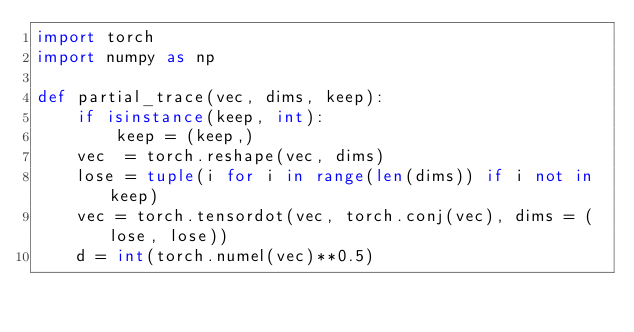<code> <loc_0><loc_0><loc_500><loc_500><_Python_>import torch
import numpy as np

def partial_trace(vec, dims, keep):
    if isinstance(keep, int):
        keep = (keep,)
    vec  = torch.reshape(vec, dims)
    lose = tuple(i for i in range(len(dims)) if i not in keep)
    vec = torch.tensordot(vec, torch.conj(vec), dims = (lose, lose))
    d = int(torch.numel(vec)**0.5)</code> 